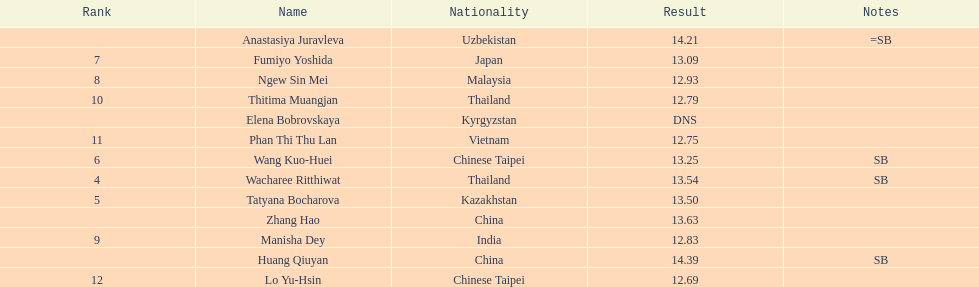What is the number of different nationalities represented by the top 5 athletes? 4. 